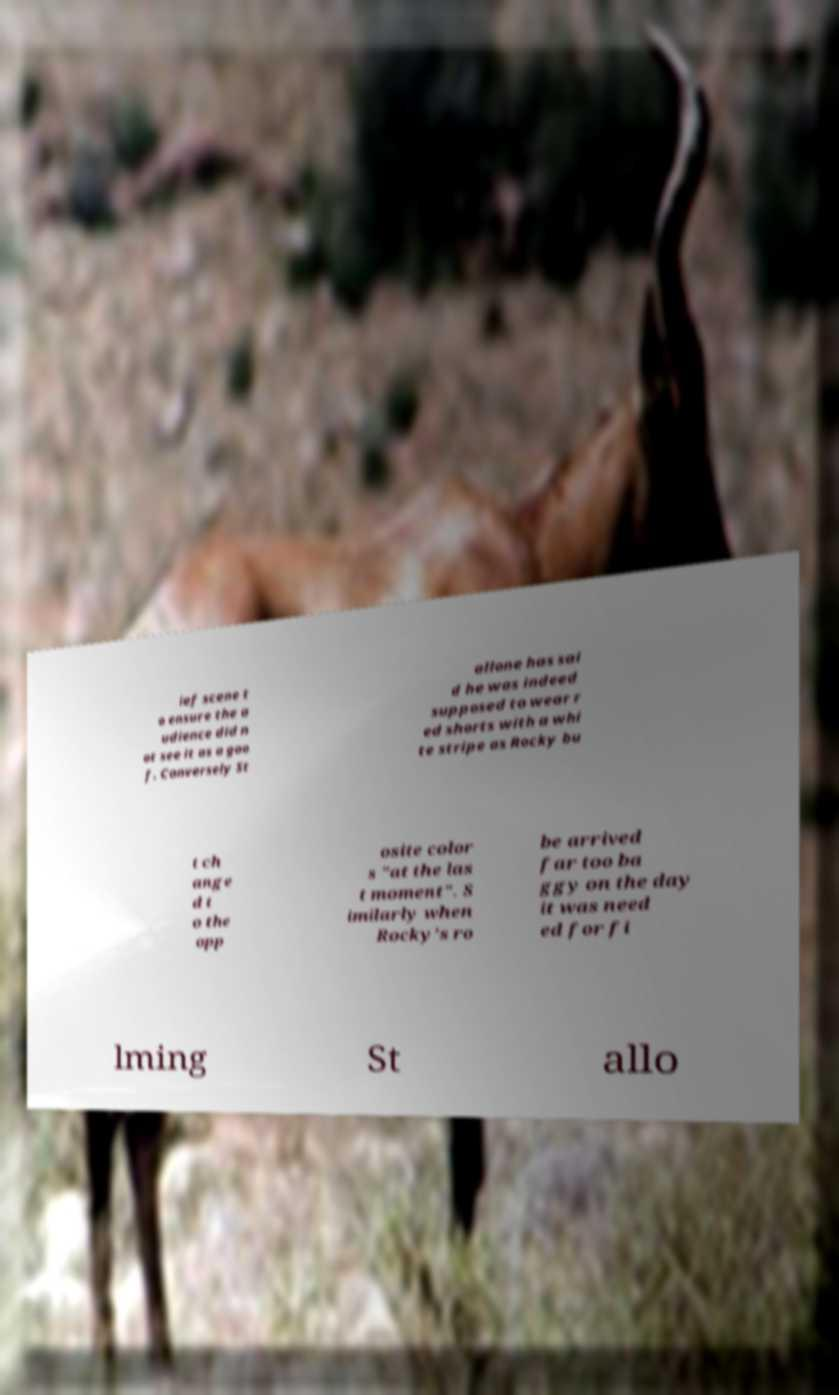For documentation purposes, I need the text within this image transcribed. Could you provide that? ief scene t o ensure the a udience did n ot see it as a goo f. Conversely St allone has sai d he was indeed supposed to wear r ed shorts with a whi te stripe as Rocky bu t ch ange d t o the opp osite color s "at the las t moment". S imilarly when Rocky's ro be arrived far too ba ggy on the day it was need ed for fi lming St allo 